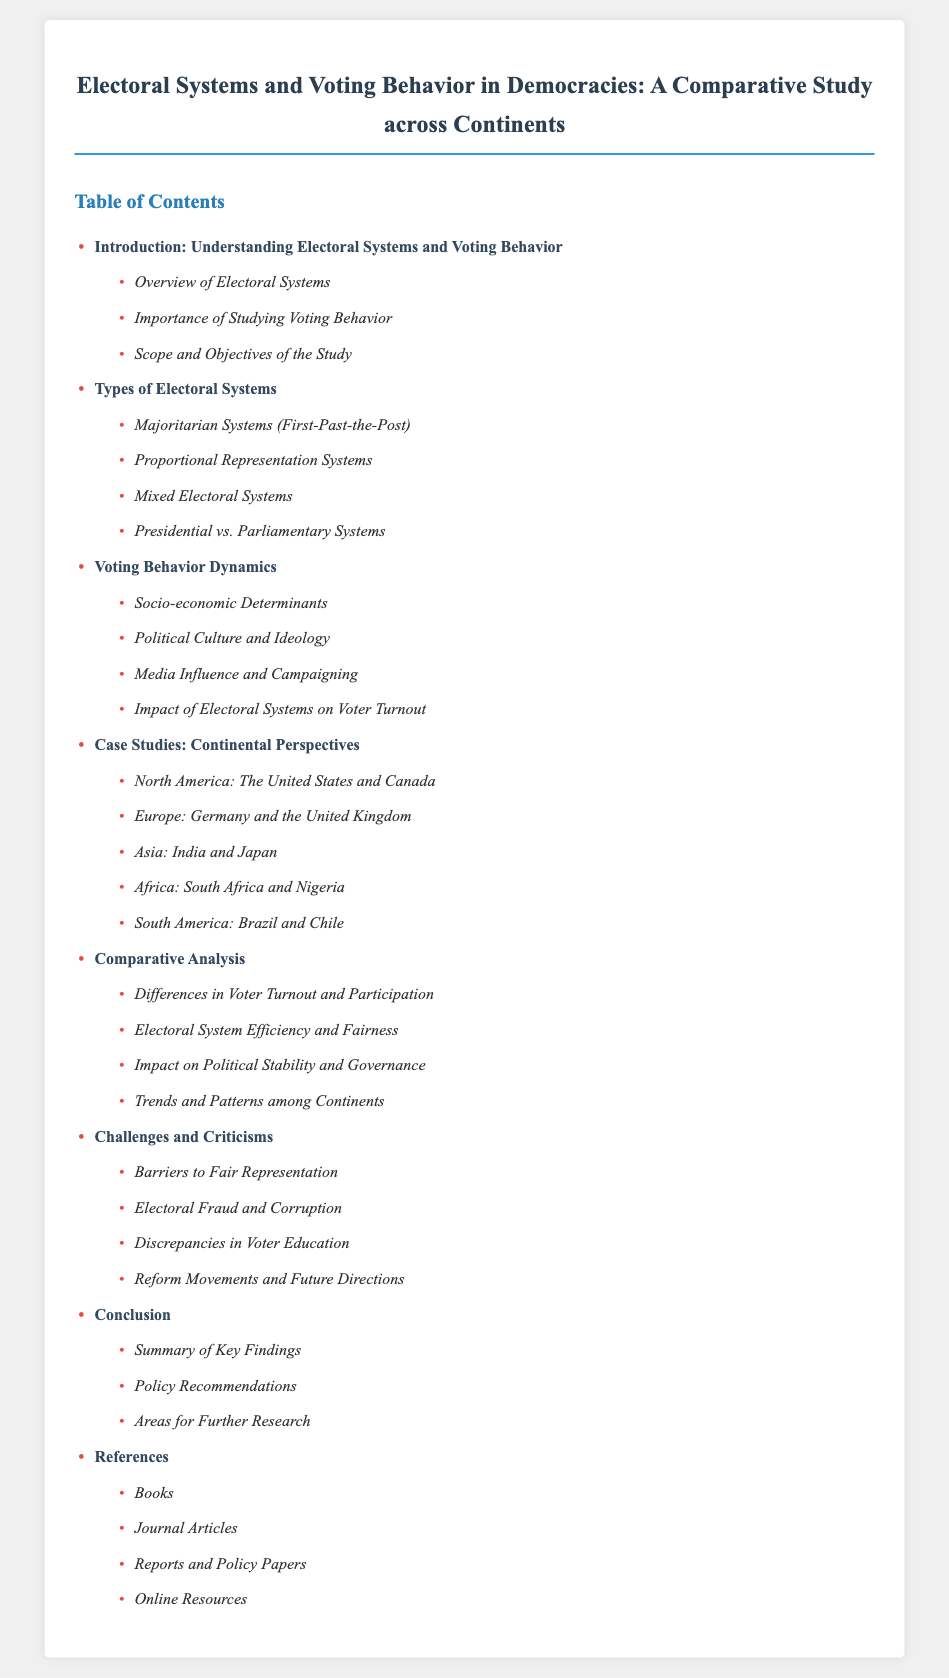What is the title of the document? The title is explicitly stated at the top of the document, summarizing its main topic.
Answer: Electoral Systems and Voting Behavior in Democracies: A Comparative Study across Continents How many chapters are presented in the Table of Contents? The number of chapters is determined by counting the listed items in the Table of Contents.
Answer: 7 Which section discusses the impact of media on voting behavior? This section is included under the Voting Behavior Dynamics chapter and specifically addresses media influence.
Answer: Media Influence and Campaigning What are two examples of countries discussed in the case studies from Asia? The countries cited are specifically listed in the Asia case studies section, highlighting a key focus of the chapter.
Answer: India and Japan What is one topic covered in the Challenges and Criticisms chapter? This chapter includes various important issues related to electoral systems, one of which is highlighted directly.
Answer: Electoral Fraud and Corruption Which chapter contains the summary of key findings? The conclusion is where the key findings of the study are summarized, reflecting on the research conducted.
Answer: Conclusion What type of electoral system is associated with "First-Past-the-Post"? This electoral system is classified within the types of electoral systems chapter, specifically labeled for clarity.
Answer: Majoritarian Systems 